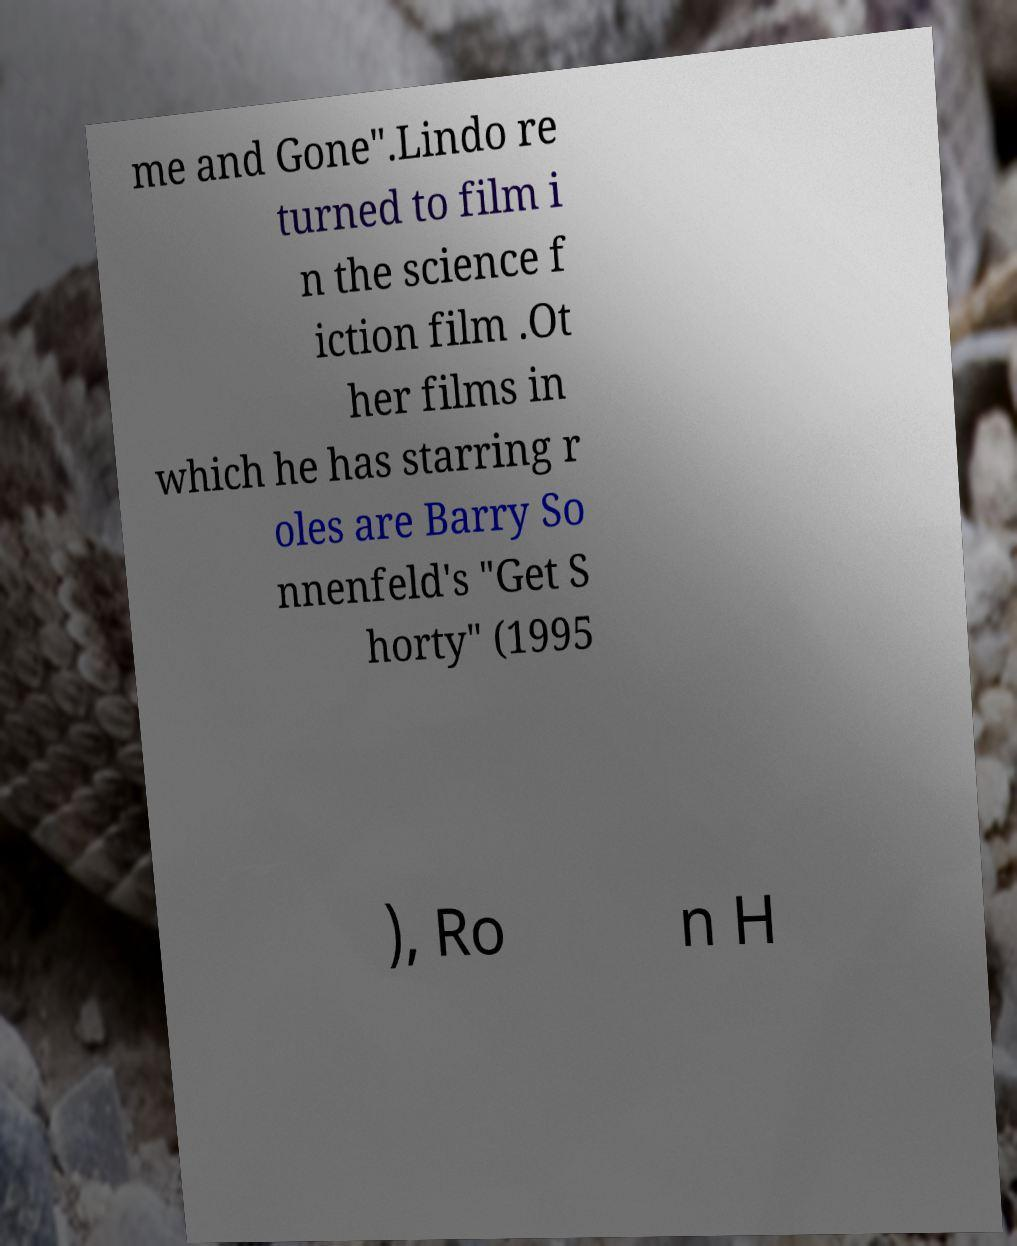There's text embedded in this image that I need extracted. Can you transcribe it verbatim? me and Gone".Lindo re turned to film i n the science f iction film .Ot her films in which he has starring r oles are Barry So nnenfeld's "Get S horty" (1995 ), Ro n H 